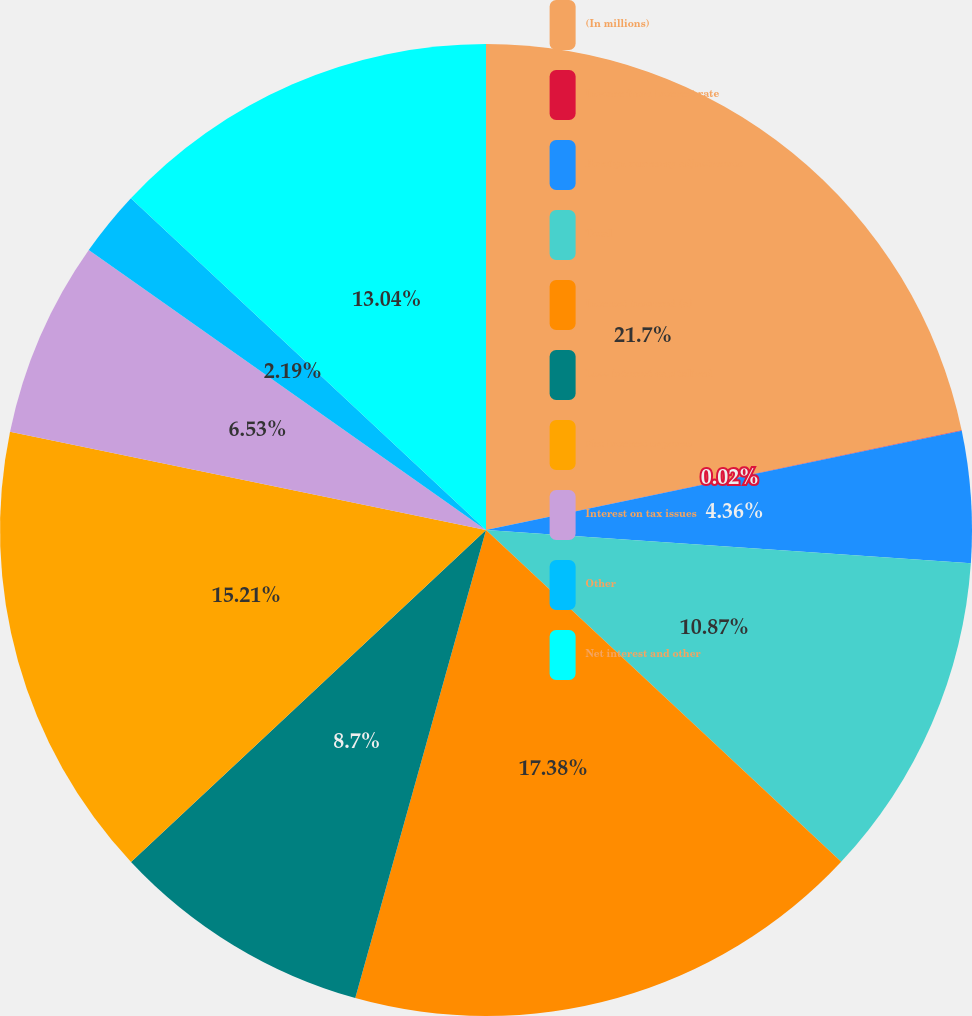Convert chart to OTSL. <chart><loc_0><loc_0><loc_500><loc_500><pie_chart><fcel>(In millions)<fcel>Income from interest rate<fcel>Foreign currency adjustments<fcel>Total<fcel>Interest incurred (a)<fcel>Less interest capitalized<fcel>Net interest expense<fcel>Interest on tax issues<fcel>Other<fcel>Net interest and other<nl><fcel>21.71%<fcel>0.02%<fcel>4.36%<fcel>10.87%<fcel>17.38%<fcel>8.7%<fcel>15.21%<fcel>6.53%<fcel>2.19%<fcel>13.04%<nl></chart> 